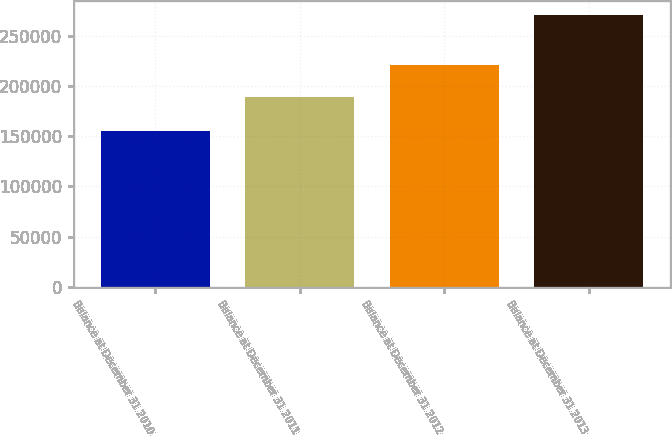<chart> <loc_0><loc_0><loc_500><loc_500><bar_chart><fcel>Balance at December 31 2010<fcel>Balance at December 31 2011<fcel>Balance at December 31 2012<fcel>Balance at December 31 2013<nl><fcel>155463<fcel>189282<fcel>220752<fcel>270397<nl></chart> 